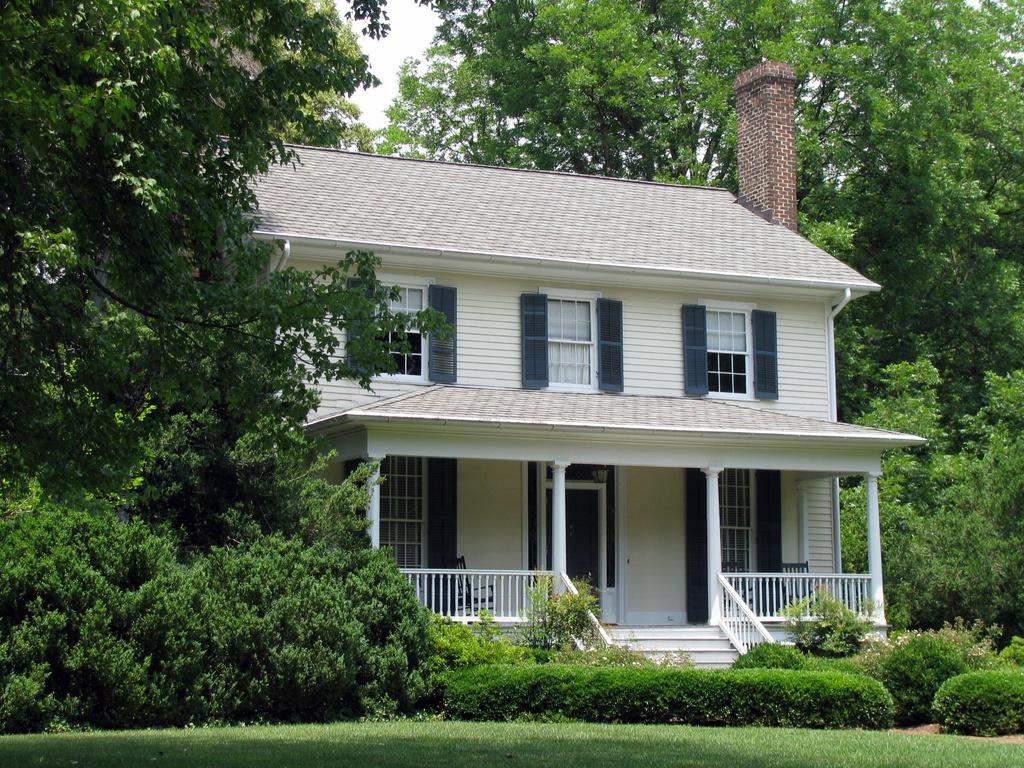What type of vegetation is present on the ground in the front of the image? There is grass on the ground in the front of the image. What can be seen in the center of the image? There are plants in the center of the image. What type of structure is visible in the background of the image? There is a house in the background of the image. What other natural elements can be seen in the background of the image? There are trees in the background of the image. What type of noise is being made by the dad in the image? There is no dad present in the image, so it is not possible to determine what noise he might be making. 